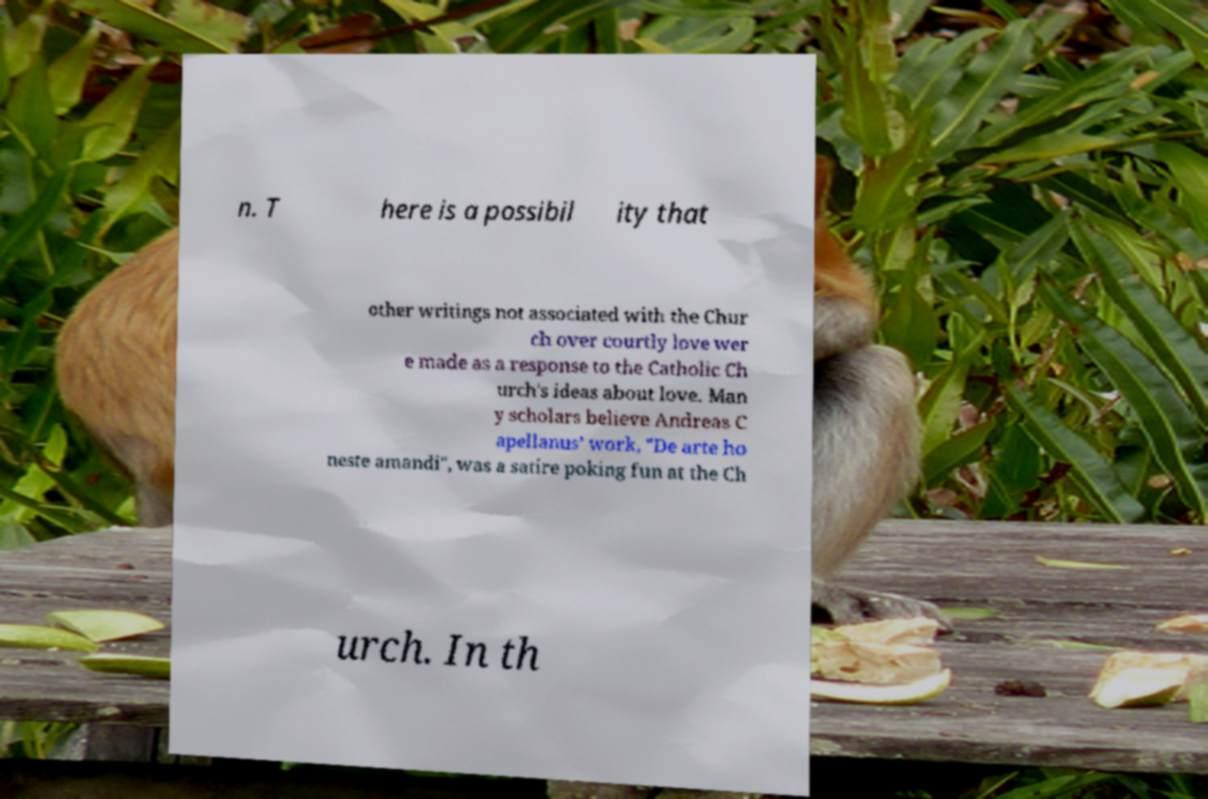I need the written content from this picture converted into text. Can you do that? n. T here is a possibil ity that other writings not associated with the Chur ch over courtly love wer e made as a response to the Catholic Ch urch's ideas about love. Man y scholars believe Andreas C apellanus’ work, "De arte ho neste amandi", was a satire poking fun at the Ch urch. In th 